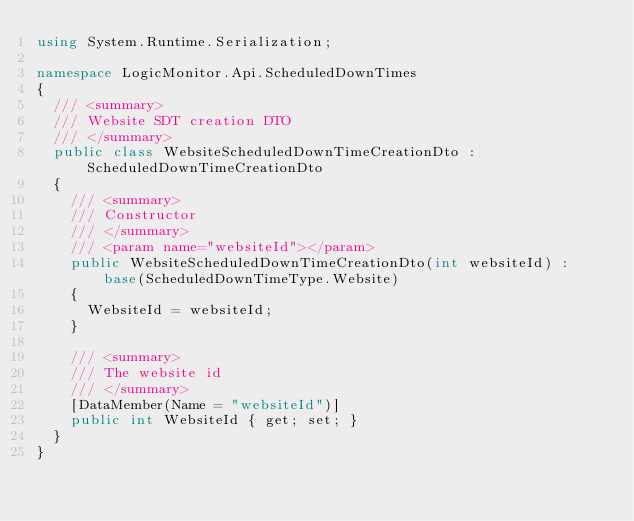Convert code to text. <code><loc_0><loc_0><loc_500><loc_500><_C#_>using System.Runtime.Serialization;

namespace LogicMonitor.Api.ScheduledDownTimes
{
	/// <summary>
	/// Website SDT creation DTO
	/// </summary>
	public class WebsiteScheduledDownTimeCreationDto : ScheduledDownTimeCreationDto
	{
		/// <summary>
		/// Constructor
		/// </summary>
		/// <param name="websiteId"></param>
		public WebsiteScheduledDownTimeCreationDto(int websiteId) : base(ScheduledDownTimeType.Website)
		{
			WebsiteId = websiteId;
		}

		/// <summary>
		/// The website id
		/// </summary>
		[DataMember(Name = "websiteId")]
		public int WebsiteId { get; set; }
	}
}</code> 